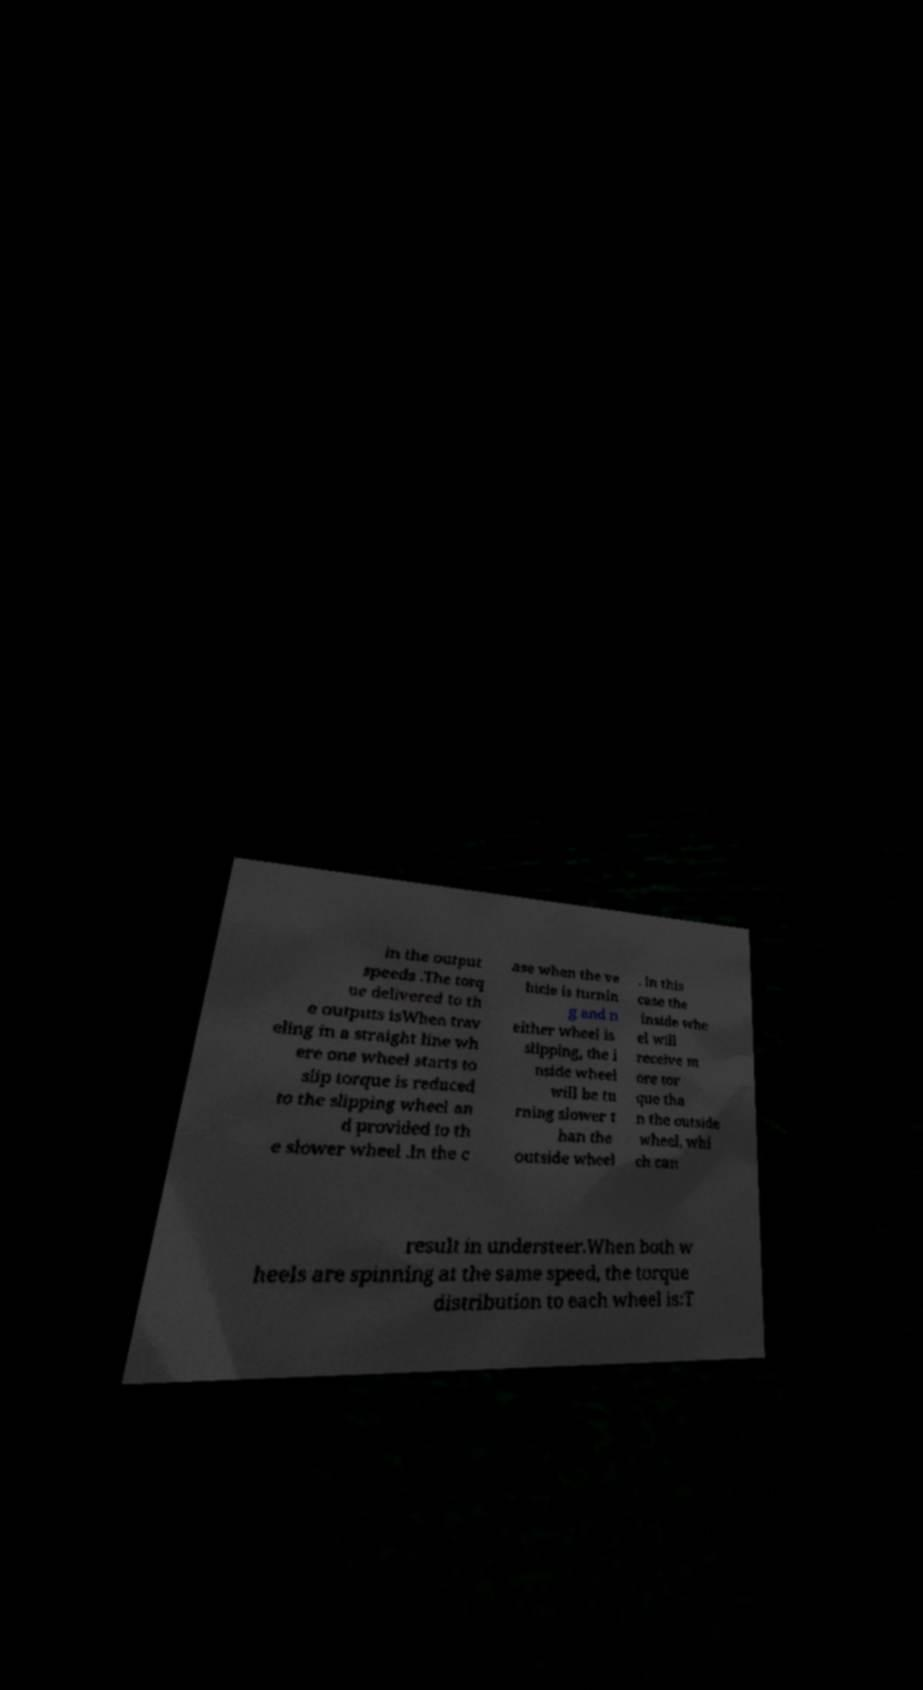Could you assist in decoding the text presented in this image and type it out clearly? in the output speeds .The torq ue delivered to th e outputs isWhen trav eling in a straight line wh ere one wheel starts to slip torque is reduced to the slipping wheel an d provided to th e slower wheel .In the c ase when the ve hicle is turnin g and n either wheel is slipping, the i nside wheel will be tu rning slower t han the outside wheel . In this case the inside whe el will receive m ore tor que tha n the outside wheel, whi ch can result in understeer.When both w heels are spinning at the same speed, the torque distribution to each wheel is:T 